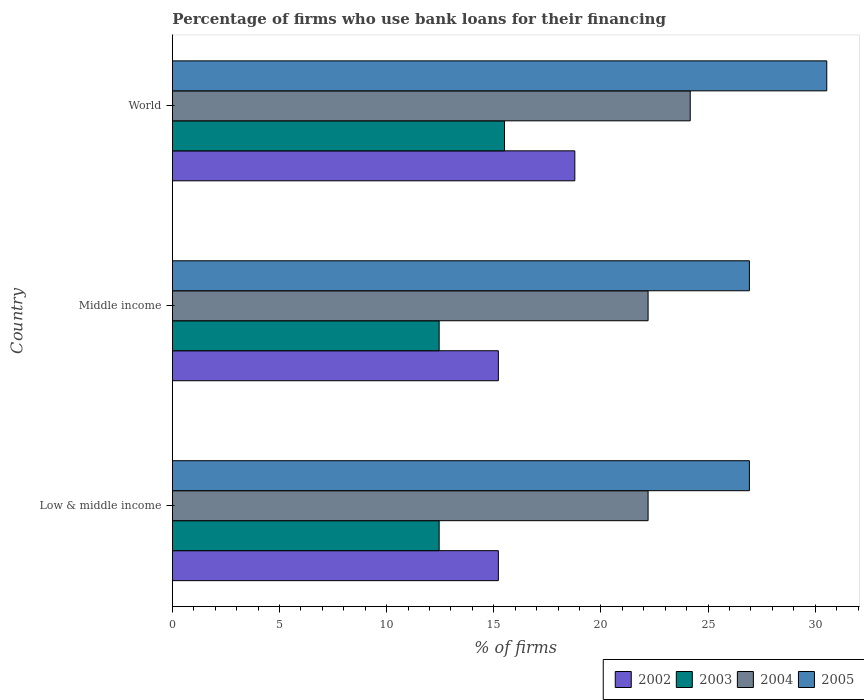How many different coloured bars are there?
Your answer should be very brief. 4. How many groups of bars are there?
Make the answer very short. 3. Are the number of bars per tick equal to the number of legend labels?
Your answer should be compact. Yes. Are the number of bars on each tick of the Y-axis equal?
Give a very brief answer. Yes. How many bars are there on the 1st tick from the top?
Give a very brief answer. 4. What is the percentage of firms who use bank loans for their financing in 2002 in Low & middle income?
Offer a very short reply. 15.21. Across all countries, what is the maximum percentage of firms who use bank loans for their financing in 2002?
Ensure brevity in your answer.  18.78. In which country was the percentage of firms who use bank loans for their financing in 2004 minimum?
Ensure brevity in your answer.  Low & middle income. What is the total percentage of firms who use bank loans for their financing in 2003 in the graph?
Ensure brevity in your answer.  40.4. What is the difference between the percentage of firms who use bank loans for their financing in 2005 in Low & middle income and that in World?
Make the answer very short. -3.61. What is the difference between the percentage of firms who use bank loans for their financing in 2003 in Middle income and the percentage of firms who use bank loans for their financing in 2004 in World?
Provide a short and direct response. -11.72. What is the average percentage of firms who use bank loans for their financing in 2003 per country?
Give a very brief answer. 13.47. What is the difference between the percentage of firms who use bank loans for their financing in 2002 and percentage of firms who use bank loans for their financing in 2005 in Low & middle income?
Offer a terse response. -11.72. What is the ratio of the percentage of firms who use bank loans for their financing in 2005 in Low & middle income to that in Middle income?
Give a very brief answer. 1. What is the difference between the highest and the second highest percentage of firms who use bank loans for their financing in 2002?
Offer a very short reply. 3.57. What is the difference between the highest and the lowest percentage of firms who use bank loans for their financing in 2002?
Keep it short and to the point. 3.57. In how many countries, is the percentage of firms who use bank loans for their financing in 2005 greater than the average percentage of firms who use bank loans for their financing in 2005 taken over all countries?
Give a very brief answer. 1. Is the sum of the percentage of firms who use bank loans for their financing in 2003 in Middle income and World greater than the maximum percentage of firms who use bank loans for their financing in 2004 across all countries?
Your answer should be very brief. Yes. Is it the case that in every country, the sum of the percentage of firms who use bank loans for their financing in 2003 and percentage of firms who use bank loans for their financing in 2004 is greater than the sum of percentage of firms who use bank loans for their financing in 2005 and percentage of firms who use bank loans for their financing in 2002?
Provide a succinct answer. No. How many countries are there in the graph?
Your answer should be compact. 3. Are the values on the major ticks of X-axis written in scientific E-notation?
Keep it short and to the point. No. Does the graph contain any zero values?
Provide a short and direct response. No. What is the title of the graph?
Give a very brief answer. Percentage of firms who use bank loans for their financing. Does "1993" appear as one of the legend labels in the graph?
Your answer should be compact. No. What is the label or title of the X-axis?
Your response must be concise. % of firms. What is the % of firms of 2002 in Low & middle income?
Ensure brevity in your answer.  15.21. What is the % of firms of 2003 in Low & middle income?
Keep it short and to the point. 12.45. What is the % of firms of 2004 in Low & middle income?
Keep it short and to the point. 22.2. What is the % of firms in 2005 in Low & middle income?
Your answer should be very brief. 26.93. What is the % of firms of 2002 in Middle income?
Make the answer very short. 15.21. What is the % of firms of 2003 in Middle income?
Your response must be concise. 12.45. What is the % of firms in 2005 in Middle income?
Keep it short and to the point. 26.93. What is the % of firms in 2002 in World?
Your answer should be very brief. 18.78. What is the % of firms of 2004 in World?
Offer a very short reply. 24.17. What is the % of firms of 2005 in World?
Offer a very short reply. 30.54. Across all countries, what is the maximum % of firms in 2002?
Make the answer very short. 18.78. Across all countries, what is the maximum % of firms in 2004?
Provide a succinct answer. 24.17. Across all countries, what is the maximum % of firms of 2005?
Provide a succinct answer. 30.54. Across all countries, what is the minimum % of firms in 2002?
Offer a very short reply. 15.21. Across all countries, what is the minimum % of firms in 2003?
Keep it short and to the point. 12.45. Across all countries, what is the minimum % of firms of 2005?
Your answer should be compact. 26.93. What is the total % of firms of 2002 in the graph?
Make the answer very short. 49.21. What is the total % of firms in 2003 in the graph?
Keep it short and to the point. 40.4. What is the total % of firms of 2004 in the graph?
Offer a very short reply. 68.57. What is the total % of firms of 2005 in the graph?
Provide a succinct answer. 84.39. What is the difference between the % of firms in 2003 in Low & middle income and that in Middle income?
Offer a terse response. 0. What is the difference between the % of firms in 2005 in Low & middle income and that in Middle income?
Provide a succinct answer. 0. What is the difference between the % of firms in 2002 in Low & middle income and that in World?
Offer a terse response. -3.57. What is the difference between the % of firms in 2003 in Low & middle income and that in World?
Offer a very short reply. -3.05. What is the difference between the % of firms in 2004 in Low & middle income and that in World?
Provide a succinct answer. -1.97. What is the difference between the % of firms in 2005 in Low & middle income and that in World?
Keep it short and to the point. -3.61. What is the difference between the % of firms of 2002 in Middle income and that in World?
Provide a succinct answer. -3.57. What is the difference between the % of firms in 2003 in Middle income and that in World?
Ensure brevity in your answer.  -3.05. What is the difference between the % of firms in 2004 in Middle income and that in World?
Your answer should be very brief. -1.97. What is the difference between the % of firms in 2005 in Middle income and that in World?
Make the answer very short. -3.61. What is the difference between the % of firms in 2002 in Low & middle income and the % of firms in 2003 in Middle income?
Offer a terse response. 2.76. What is the difference between the % of firms in 2002 in Low & middle income and the % of firms in 2004 in Middle income?
Your answer should be compact. -6.99. What is the difference between the % of firms in 2002 in Low & middle income and the % of firms in 2005 in Middle income?
Offer a terse response. -11.72. What is the difference between the % of firms of 2003 in Low & middle income and the % of firms of 2004 in Middle income?
Offer a terse response. -9.75. What is the difference between the % of firms of 2003 in Low & middle income and the % of firms of 2005 in Middle income?
Provide a short and direct response. -14.48. What is the difference between the % of firms in 2004 in Low & middle income and the % of firms in 2005 in Middle income?
Offer a terse response. -4.73. What is the difference between the % of firms in 2002 in Low & middle income and the % of firms in 2003 in World?
Provide a short and direct response. -0.29. What is the difference between the % of firms of 2002 in Low & middle income and the % of firms of 2004 in World?
Ensure brevity in your answer.  -8.95. What is the difference between the % of firms in 2002 in Low & middle income and the % of firms in 2005 in World?
Offer a very short reply. -15.33. What is the difference between the % of firms of 2003 in Low & middle income and the % of firms of 2004 in World?
Your response must be concise. -11.72. What is the difference between the % of firms of 2003 in Low & middle income and the % of firms of 2005 in World?
Your answer should be compact. -18.09. What is the difference between the % of firms of 2004 in Low & middle income and the % of firms of 2005 in World?
Your answer should be compact. -8.34. What is the difference between the % of firms of 2002 in Middle income and the % of firms of 2003 in World?
Offer a very short reply. -0.29. What is the difference between the % of firms in 2002 in Middle income and the % of firms in 2004 in World?
Make the answer very short. -8.95. What is the difference between the % of firms in 2002 in Middle income and the % of firms in 2005 in World?
Keep it short and to the point. -15.33. What is the difference between the % of firms of 2003 in Middle income and the % of firms of 2004 in World?
Offer a very short reply. -11.72. What is the difference between the % of firms of 2003 in Middle income and the % of firms of 2005 in World?
Your answer should be very brief. -18.09. What is the difference between the % of firms of 2004 in Middle income and the % of firms of 2005 in World?
Your answer should be compact. -8.34. What is the average % of firms of 2002 per country?
Ensure brevity in your answer.  16.4. What is the average % of firms of 2003 per country?
Make the answer very short. 13.47. What is the average % of firms in 2004 per country?
Offer a terse response. 22.86. What is the average % of firms of 2005 per country?
Keep it short and to the point. 28.13. What is the difference between the % of firms of 2002 and % of firms of 2003 in Low & middle income?
Offer a very short reply. 2.76. What is the difference between the % of firms of 2002 and % of firms of 2004 in Low & middle income?
Ensure brevity in your answer.  -6.99. What is the difference between the % of firms in 2002 and % of firms in 2005 in Low & middle income?
Offer a very short reply. -11.72. What is the difference between the % of firms of 2003 and % of firms of 2004 in Low & middle income?
Keep it short and to the point. -9.75. What is the difference between the % of firms of 2003 and % of firms of 2005 in Low & middle income?
Ensure brevity in your answer.  -14.48. What is the difference between the % of firms in 2004 and % of firms in 2005 in Low & middle income?
Your response must be concise. -4.73. What is the difference between the % of firms in 2002 and % of firms in 2003 in Middle income?
Provide a short and direct response. 2.76. What is the difference between the % of firms of 2002 and % of firms of 2004 in Middle income?
Offer a terse response. -6.99. What is the difference between the % of firms of 2002 and % of firms of 2005 in Middle income?
Make the answer very short. -11.72. What is the difference between the % of firms of 2003 and % of firms of 2004 in Middle income?
Keep it short and to the point. -9.75. What is the difference between the % of firms in 2003 and % of firms in 2005 in Middle income?
Offer a very short reply. -14.48. What is the difference between the % of firms of 2004 and % of firms of 2005 in Middle income?
Give a very brief answer. -4.73. What is the difference between the % of firms in 2002 and % of firms in 2003 in World?
Your answer should be compact. 3.28. What is the difference between the % of firms of 2002 and % of firms of 2004 in World?
Your response must be concise. -5.39. What is the difference between the % of firms in 2002 and % of firms in 2005 in World?
Your answer should be very brief. -11.76. What is the difference between the % of firms of 2003 and % of firms of 2004 in World?
Ensure brevity in your answer.  -8.67. What is the difference between the % of firms of 2003 and % of firms of 2005 in World?
Keep it short and to the point. -15.04. What is the difference between the % of firms in 2004 and % of firms in 2005 in World?
Your response must be concise. -6.37. What is the ratio of the % of firms of 2003 in Low & middle income to that in Middle income?
Provide a succinct answer. 1. What is the ratio of the % of firms in 2005 in Low & middle income to that in Middle income?
Provide a short and direct response. 1. What is the ratio of the % of firms in 2002 in Low & middle income to that in World?
Offer a very short reply. 0.81. What is the ratio of the % of firms in 2003 in Low & middle income to that in World?
Provide a short and direct response. 0.8. What is the ratio of the % of firms of 2004 in Low & middle income to that in World?
Ensure brevity in your answer.  0.92. What is the ratio of the % of firms of 2005 in Low & middle income to that in World?
Ensure brevity in your answer.  0.88. What is the ratio of the % of firms of 2002 in Middle income to that in World?
Your response must be concise. 0.81. What is the ratio of the % of firms of 2003 in Middle income to that in World?
Make the answer very short. 0.8. What is the ratio of the % of firms of 2004 in Middle income to that in World?
Provide a succinct answer. 0.92. What is the ratio of the % of firms of 2005 in Middle income to that in World?
Provide a succinct answer. 0.88. What is the difference between the highest and the second highest % of firms in 2002?
Offer a terse response. 3.57. What is the difference between the highest and the second highest % of firms in 2003?
Provide a short and direct response. 3.05. What is the difference between the highest and the second highest % of firms in 2004?
Your answer should be compact. 1.97. What is the difference between the highest and the second highest % of firms of 2005?
Your response must be concise. 3.61. What is the difference between the highest and the lowest % of firms in 2002?
Keep it short and to the point. 3.57. What is the difference between the highest and the lowest % of firms in 2003?
Keep it short and to the point. 3.05. What is the difference between the highest and the lowest % of firms of 2004?
Provide a short and direct response. 1.97. What is the difference between the highest and the lowest % of firms of 2005?
Your answer should be very brief. 3.61. 